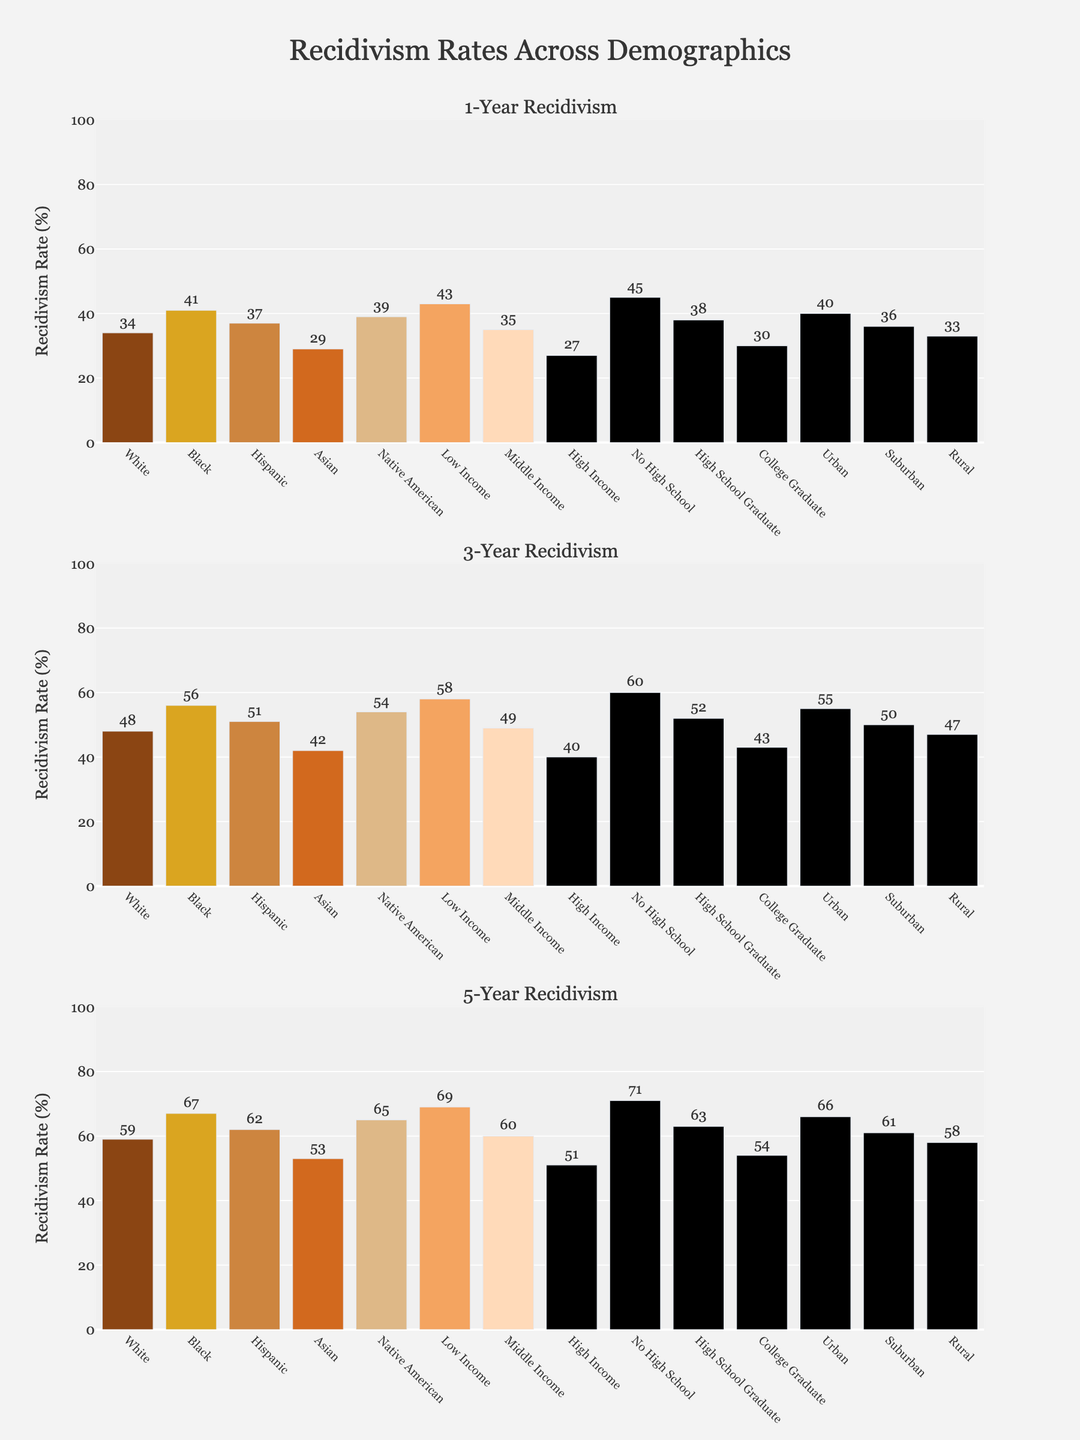What is the demographic with the highest 1-year recidivism rate? To find the demographic with the highest 1-year recidivism rate, look at the first subplot and identify the highest bar. The demographic with the bar that reaches the highest point is the one with the highest rate.
Answer: Low Income How much higher is the 1-year recidivism rate for Black individuals compared to Asian individuals? In the first subplot, find the heights of the bars for Black and Asian individuals. Black has a recidivism rate of 41% and Asians have a rate of 29%. The difference is 41% - 29%.
Answer: 12% Which income group has the lowest 5-year recidivism rate? In the third subplot, observe the bars representing different income groups. The one with the shortest bar corresponds to the group with the lowest rate.
Answer: High Income How do the 3-year recidivism rates of Native American and Hispanic demographics compare? In the second subplot, find the heights of the bars for Native American and Hispanic groups. Native American has a rate of 54%, while Hispanic has 51%. Native American has a higher rate.
Answer: Native American has a higher rate What is the average 5-year recidivism rate across all demographic groups? Find the 5-year recidivism rates in the data and sum them up: (59 + 67 + 62 + 53 + 65 + 69 + 60 + 51 + 71 + 63 + 54 + 66 + 61 + 58) = 808. There are 14 groups, so the average is 808 / 14.
Answer: 57.7 Compare the 1-year recidivism rates for Urban and Rural groups. Which is higher, and by how much? In the first subplot, find the 1-year recidivism rates for Urban and Rural groups. Urban has a rate of 40%, while Rural has 33%. The difference is 40% - 33%.
Answer: Urban is higher by 7% Which educational group has the highest 3-year recidivism rate? In the second subplot, observe the groups based on education. The group with the tallest bar has the highest rate.
Answer: No High School Does the rate of recidivism for College Graduates increase or decrease over 1-year, 3-year, and 5-year periods? Compare the College Graduate bars in all three subplots. They are 30% at 1-year, 43% at 3-year, and 54% at 5-year, showing an increasing trend.
Answer: Increase Which group shows the least increase in recidivism rates from 1-year to 5-year periods? Calculate the difference between 1-year and 5-year rates for each group and identify the smallest difference. E.g, the differences are 59-34=25, 67-41=26, ..., 58-33=25. Several groups show minimal increases, like White and Rural, for instance.
Answer: White and Rural What's the difference in 5-year recidivism rates between High School Graduates and the Urban demographic? In the third subplot, High School Graduates have a rate of 63% and Urban has 66%. The difference is 66% - 63%.
Answer: 3% 